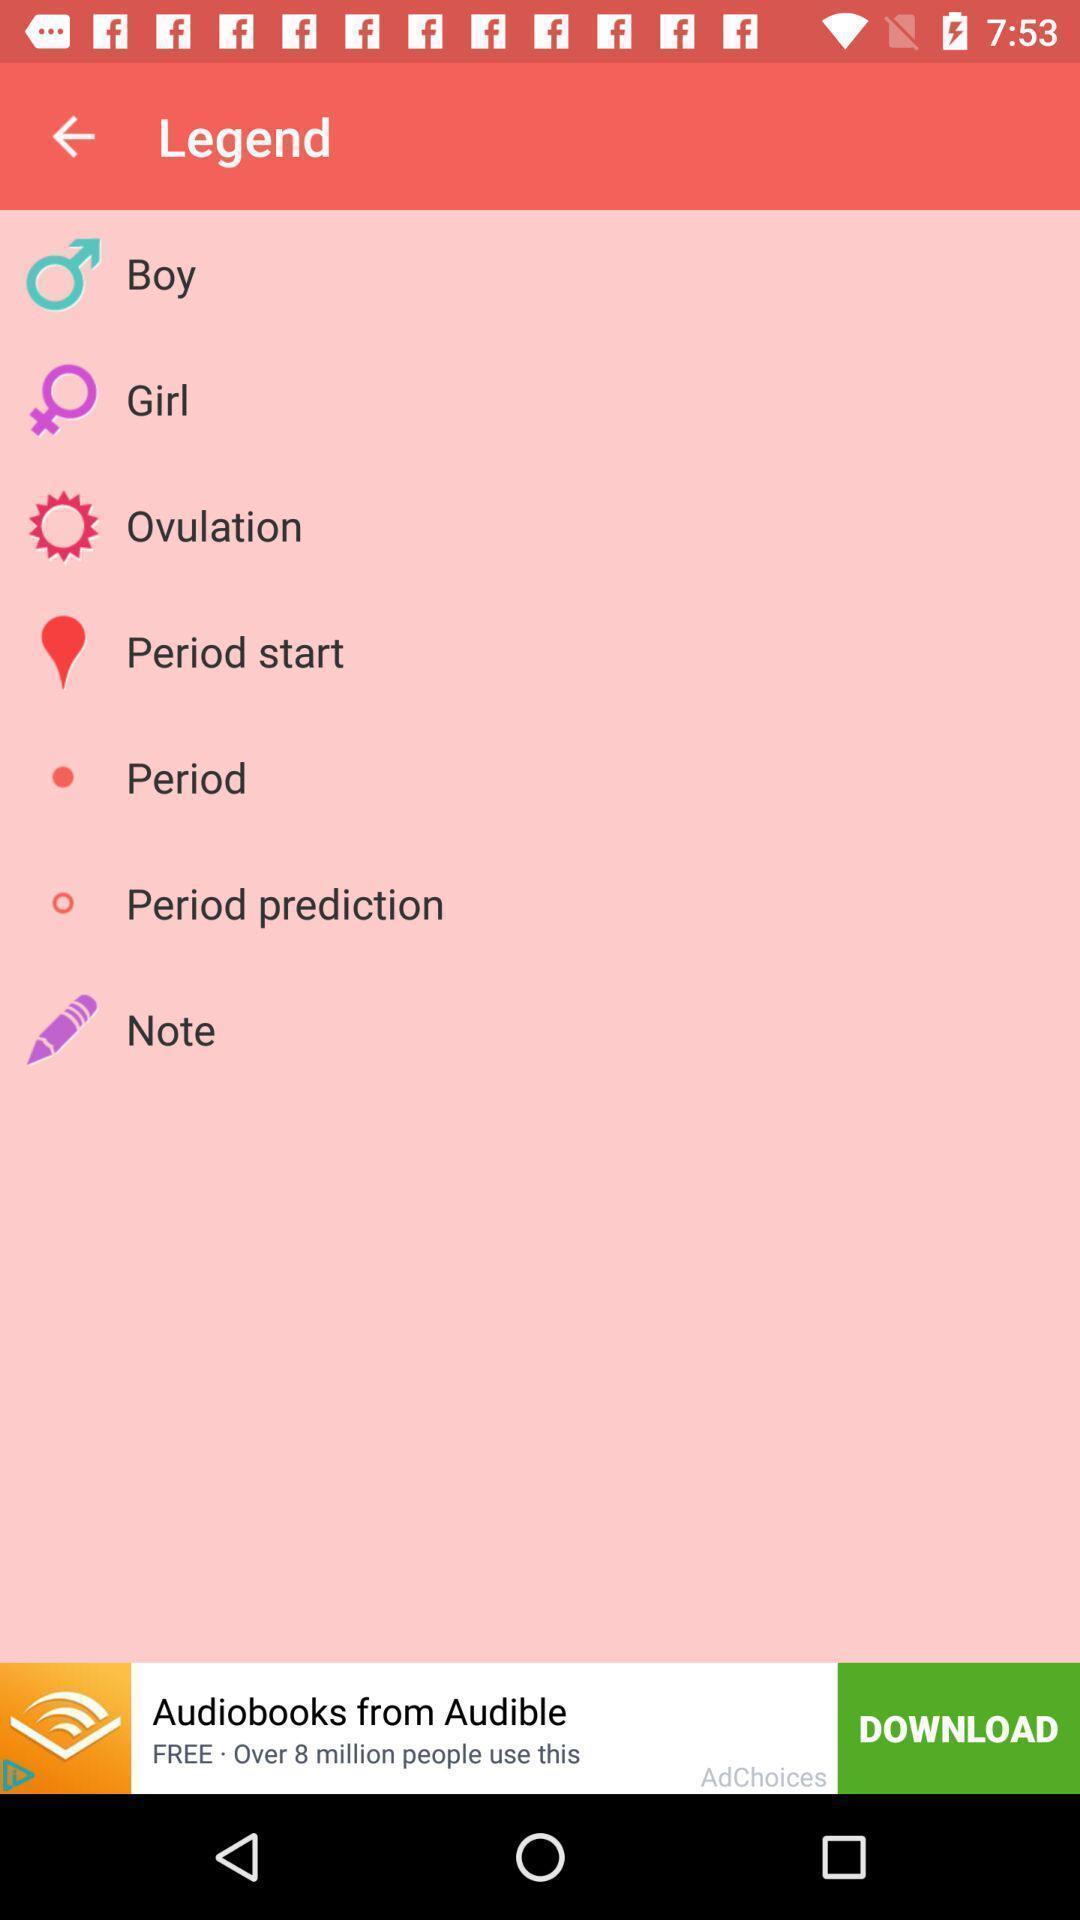Summarize the main components in this picture. Window displaying a period tracking app. 